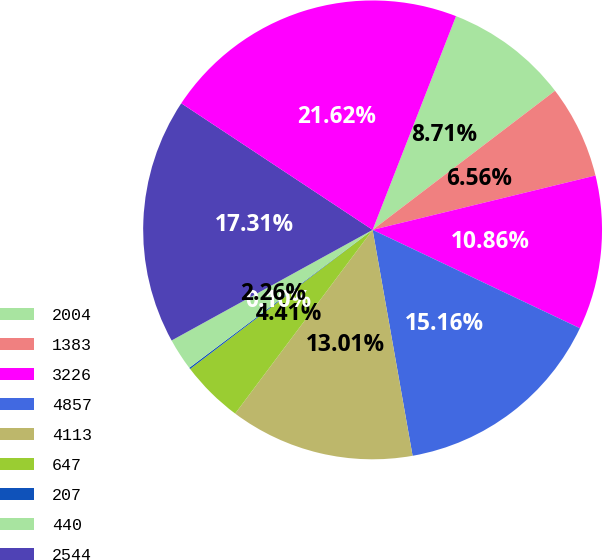<chart> <loc_0><loc_0><loc_500><loc_500><pie_chart><fcel>2004<fcel>1383<fcel>3226<fcel>4857<fcel>4113<fcel>647<fcel>207<fcel>440<fcel>2544<fcel>23430<nl><fcel>8.71%<fcel>6.56%<fcel>10.86%<fcel>15.16%<fcel>13.01%<fcel>4.41%<fcel>0.1%<fcel>2.26%<fcel>17.31%<fcel>21.62%<nl></chart> 